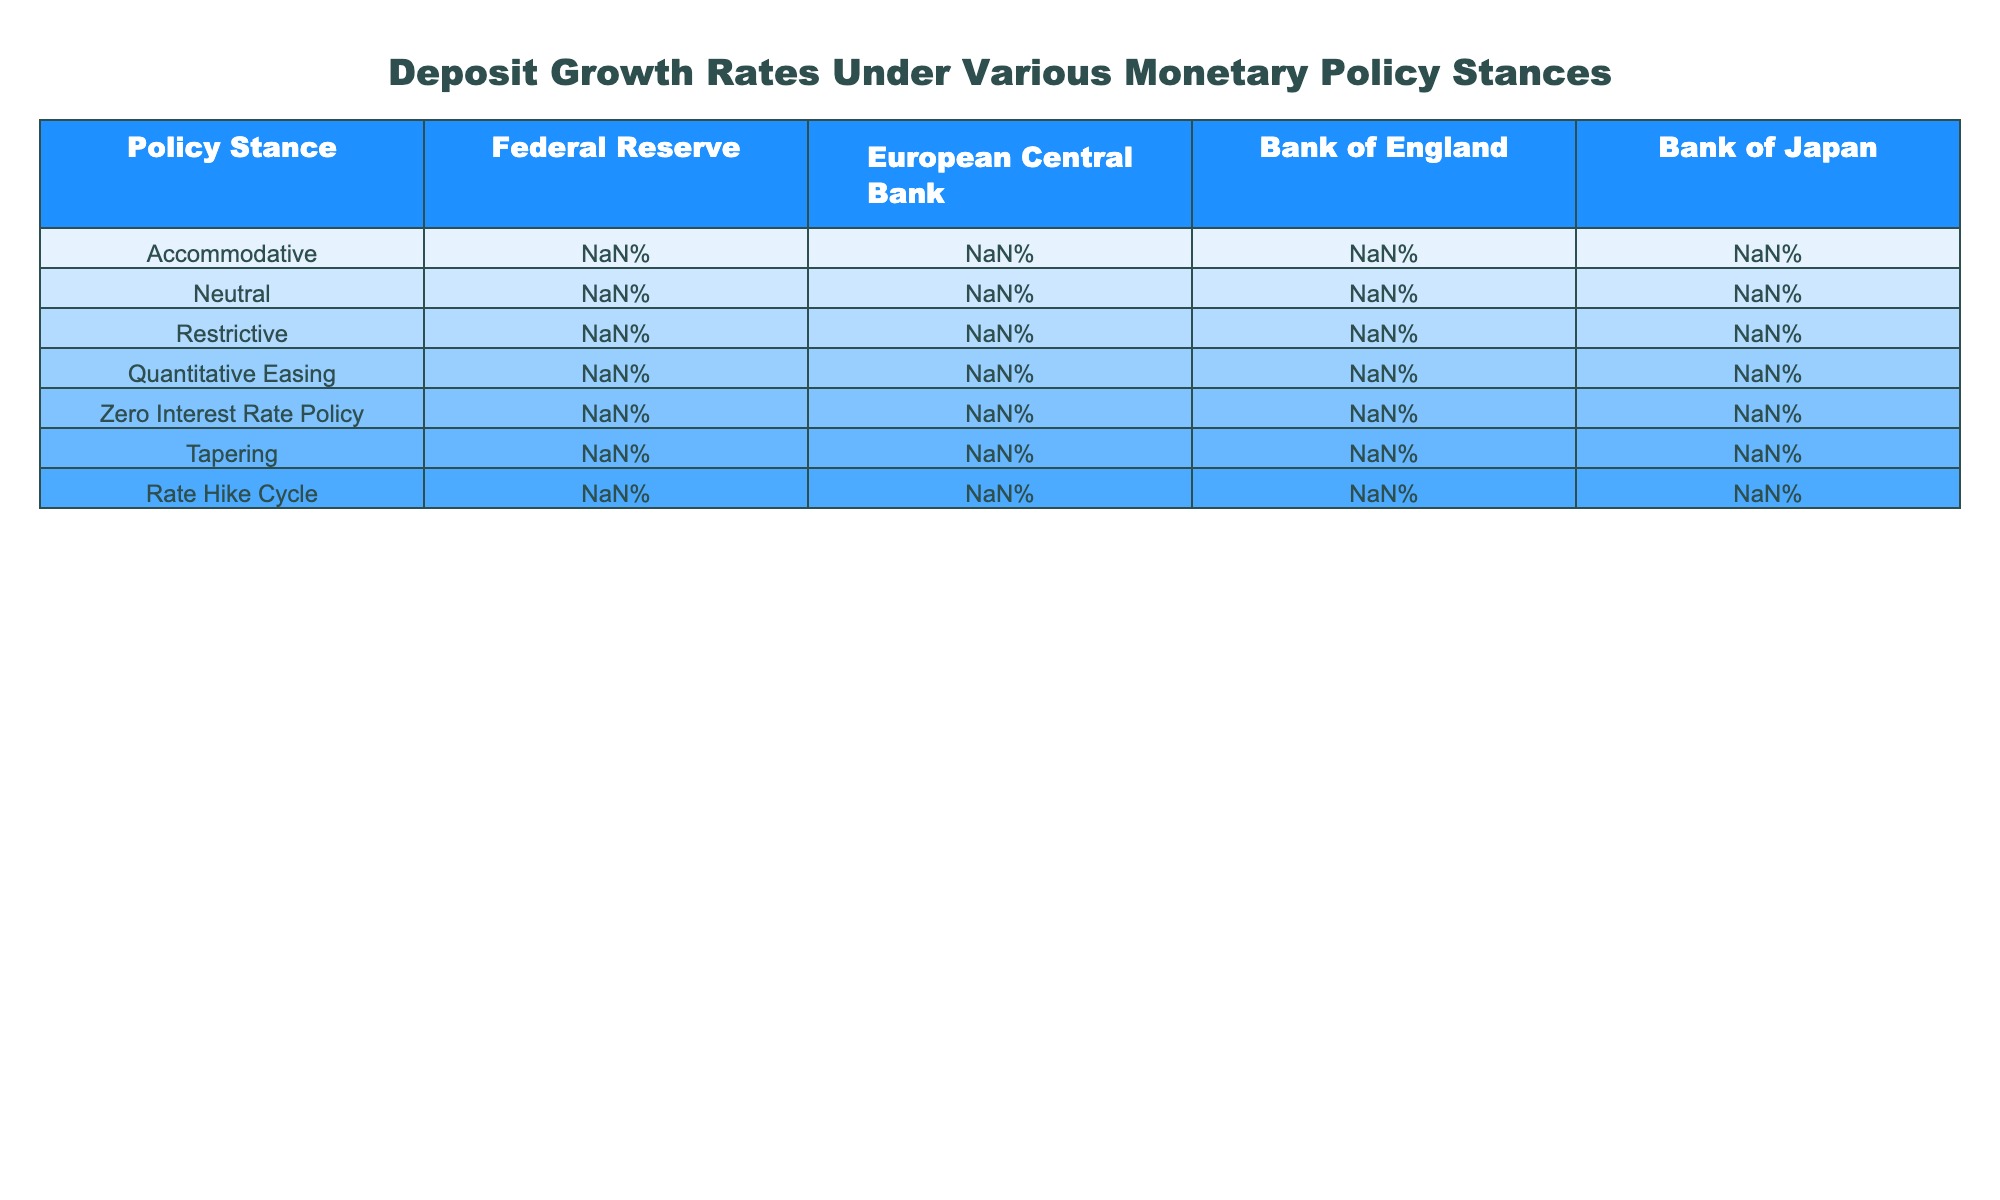What is the deposit growth rate under the accommodative policy stance for the Federal Reserve? The table shows a deposit growth rate of 3.8% under the accommodative policy stance for the Federal Reserve.
Answer: 3.8% Which central bank has the highest deposit growth rate during the quantitative easing policy stance? The table indicates that the Federal Reserve has the highest deposit growth rate of 4.5% during the quantitative easing policy stance.
Answer: Federal Reserve What is the average deposit growth rate across all central banks under the neutral policy stance? The deposit growth rates under the neutral stance are 2.5%, 1.8%, 2.1%, and 0.9%. The average is (2.5 + 1.8 + 2.1 + 0.9) / 4 = 1.83%.
Answer: 1.83% Which policy stance resulted in the lowest deposit growth rate for the Bank of England? The table shows that the lowest deposit growth rate for the Bank of England is 0.5% during the rate hike cycle.
Answer: 0.5% Is the deposit growth rate for the European Central Bank under the zero interest rate policy higher than that under the restrictive policy? The deposit growth rate under the zero interest rate policy for the European Central Bank is 2.4%, while under the restrictive policy, it is 0.7%. Since 2.4% is greater than 0.7%, the statement is true.
Answer: Yes What is the difference in deposit growth rates for the Bank of Japan between the accommodative and the tapering policy stances? The deposit growth rate under the accommodative stance for the Bank of Japan is 1.7%, and under tapering, it is 0.6%. The difference is 1.7% - 0.6% = 1.1%.
Answer: 1.1% During which policy stance does the European Central Bank show the least deposit growth? The table shows that the European Central Bank has the least deposit growth rate of 0.3% during the rate hike cycle.
Answer: Rate hike cycle Which central bank has the most significant reduction in deposit growth rate when moving from accommodative to restrictive policy stance? For the Federal Reserve, the reduction is 3.8% - 1.2% = 2.6%. For the European Central Bank, it's 2.9% - 0.7% = 2.2%. For the Bank of England, it's 3.2% - 1.0% = 2.2%. For the Bank of Japan, it's 1.7% - 0.3% = 1.4%. The largest reduction is 2.6% for the Federal Reserve.
Answer: Federal Reserve What pattern can we observe in deposit growth rates across different monetary policy stances? The table shows that deposit growth rates tend to be higher in accommodative and quantitative easing stances and decrease with more restrictive policies, indicating a negative correlation between policy restrictiveness and deposit growth.
Answer: They decrease with increased restrictiveness 